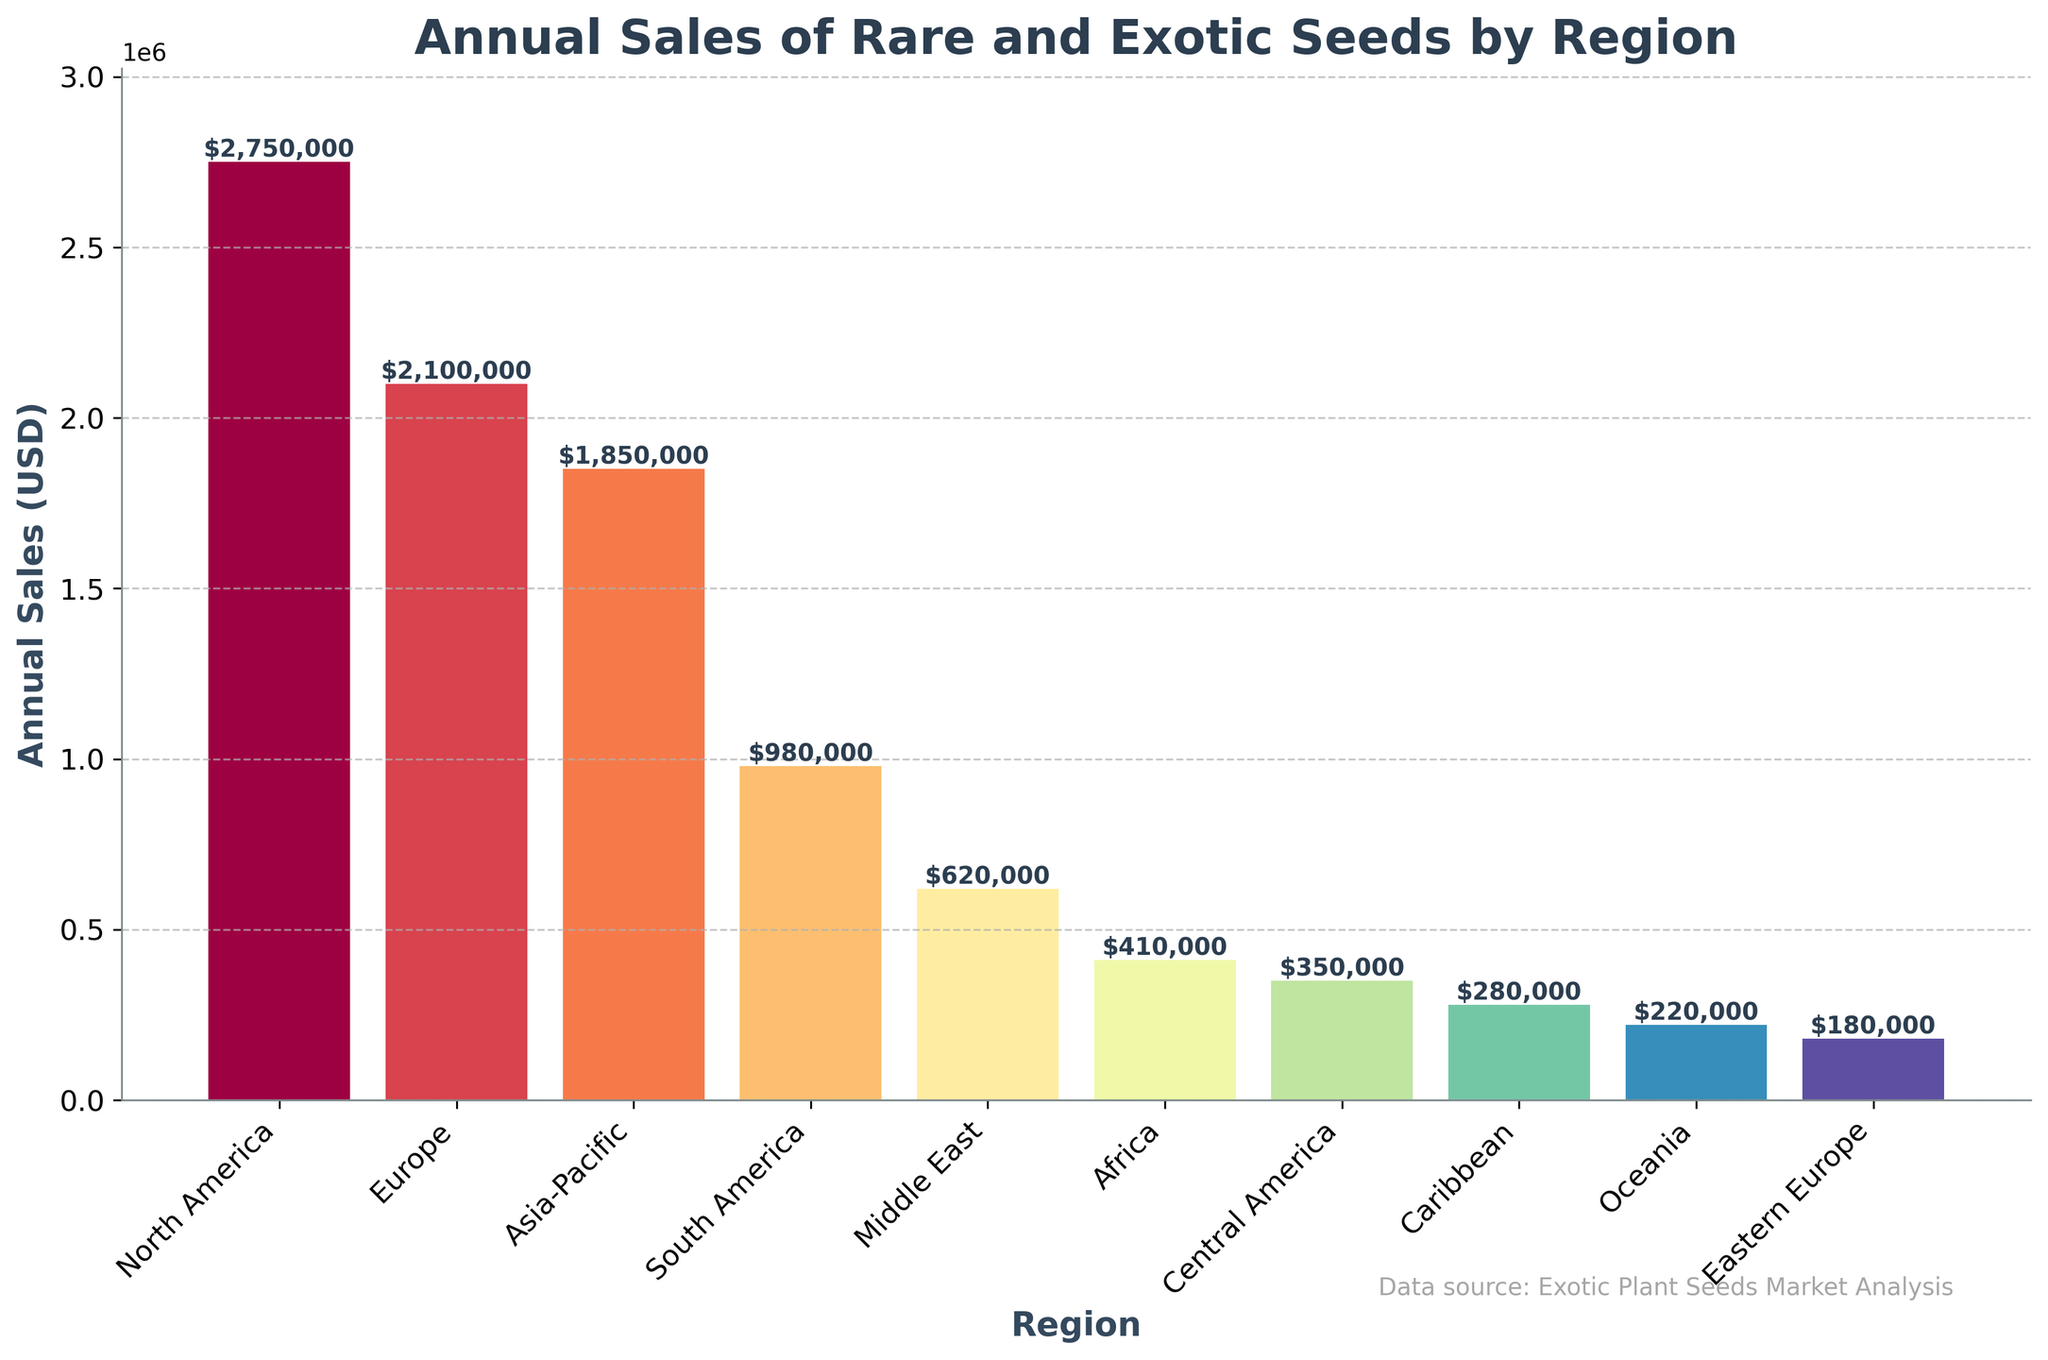What's the region with the highest annual sales? The bar corresponding to North America is the tallest in the figure, indicating the highest sales.
Answer: North America How much more are the annual sales in North America compared to Europe? The annual sales in North America are $2,750,000, and in Europe, they are $2,100,000. The difference is $2,750,000 - $2,100,000.
Answer: $650,000 Which region has the lowest annual sales of rare and exotic seeds? Observing the figure, Oceania has the shortest bar, indicating the lowest sales.
Answer: Oceania What are the combined sales of the three regions with the lowest annual sales? Oceania ($220,000), Eastern Europe ($180,000), and the Caribbean ($280,000) combined are $220,000 + $180,000 + $280,000.
Answer: $680,000 What is the annual sales difference between Asia-Pacific and South America? Asia-Pacific has $1,850,000 in sales, while South America has $980,000. The difference is $1,850,000 - $980,000.
Answer: $870,000 What is the average annual sales of regions with sales above $1,000,000? Regions: North America ($2,750,000), Europe ($2,100,000), and Asia-Pacific ($1,850,000). The average is ($2,750,000 + $2,100,000 + $1,850,000) / 3.
Answer: $2,233,333 How do the annual sales of South America compare to the Middle East? South America has higher sales with $980,000 compared to the Middle East's $620,000.
Answer: South America has higher sales What is the total sales value for all regions combined? Sum all the sales: $2,750,000 + $2,100,000 + $1,850,000 + $980,000 + $620,000 + $410,000 + $350,000 + $280,000 + $220,000 + $180,000.
Answer: $9,740,000 Which region has nearly half the sales of Europe? Europe has $2,100,000 in sales. South America with $980,000 is close to half of Europe’s sales ($1,050,000).
Answer: South America Are there more regions with sales above or below $500,000? Regions with sales above $500,000: North America, Europe, Asia-Pacific, South America, and the Middle East. Regions below $500,000: Africa, Central America, the Caribbean, Oceania, and Eastern Europe. There are 5 regions in each.
Answer: Equal 